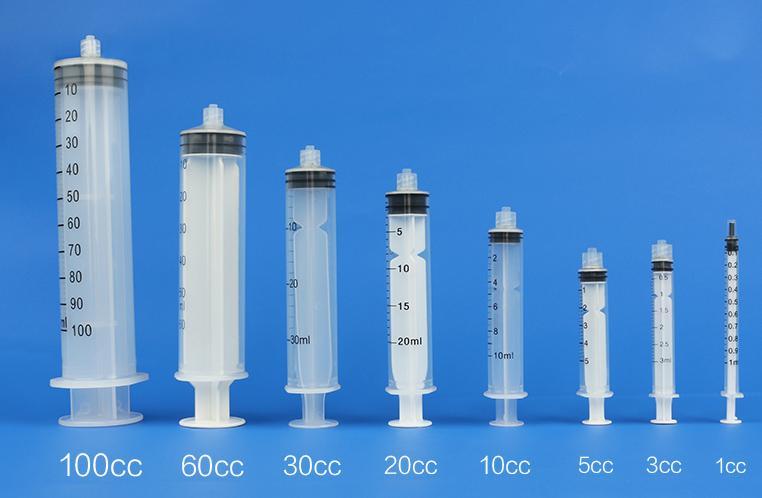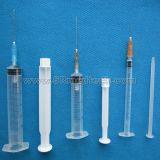The first image is the image on the left, the second image is the image on the right. Examine the images to the left and right. Is the description "Each image contains more than four syringes." accurate? Answer yes or no. Yes. The first image is the image on the left, the second image is the image on the right. Given the left and right images, does the statement "In one of the images, there are no needles attached to the syringes." hold true? Answer yes or no. Yes. 